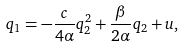<formula> <loc_0><loc_0><loc_500><loc_500>q _ { 1 } = - \frac { c } { 4 \alpha } q _ { 2 } ^ { 2 } + \frac { \beta } { 2 \alpha } q _ { 2 } + u ,</formula> 